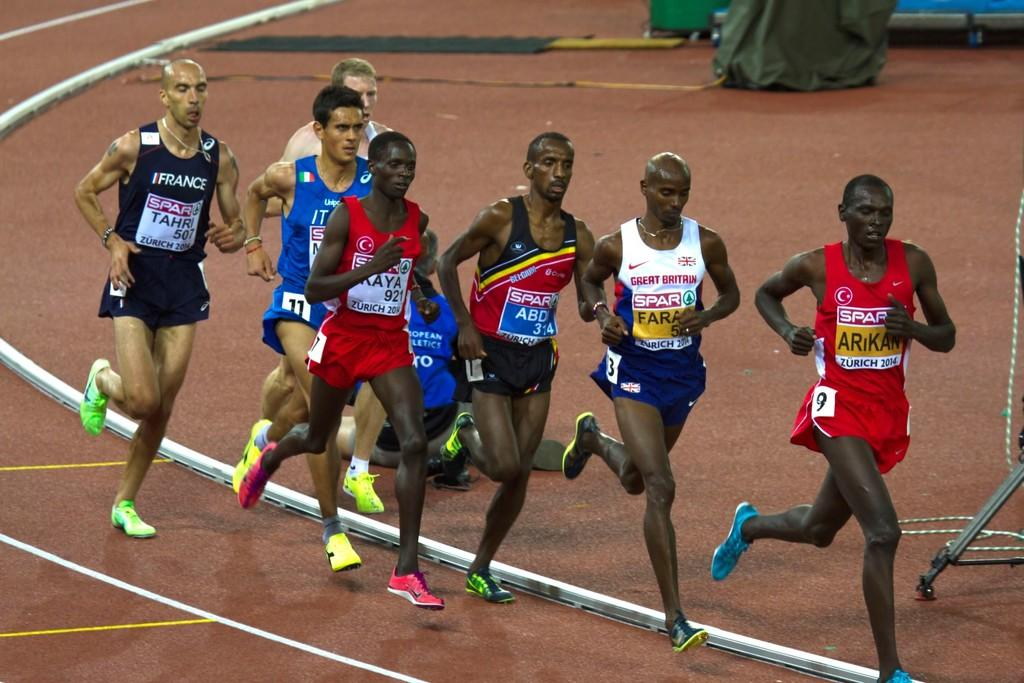What is the man on the right side of the image doing? The man on the right side of the image is running. What is the man wearing while running? The man is wearing a red dress. What can be seen happening in the middle of the image? There is a group of persons running in the middle of the image. Can you describe the lines at the bottom of the image? There are white color lines at the bottom of the image. What type of pot is being used for the division in the image? There is no pot or division present in the image; it features a man running and a group of persons running. 